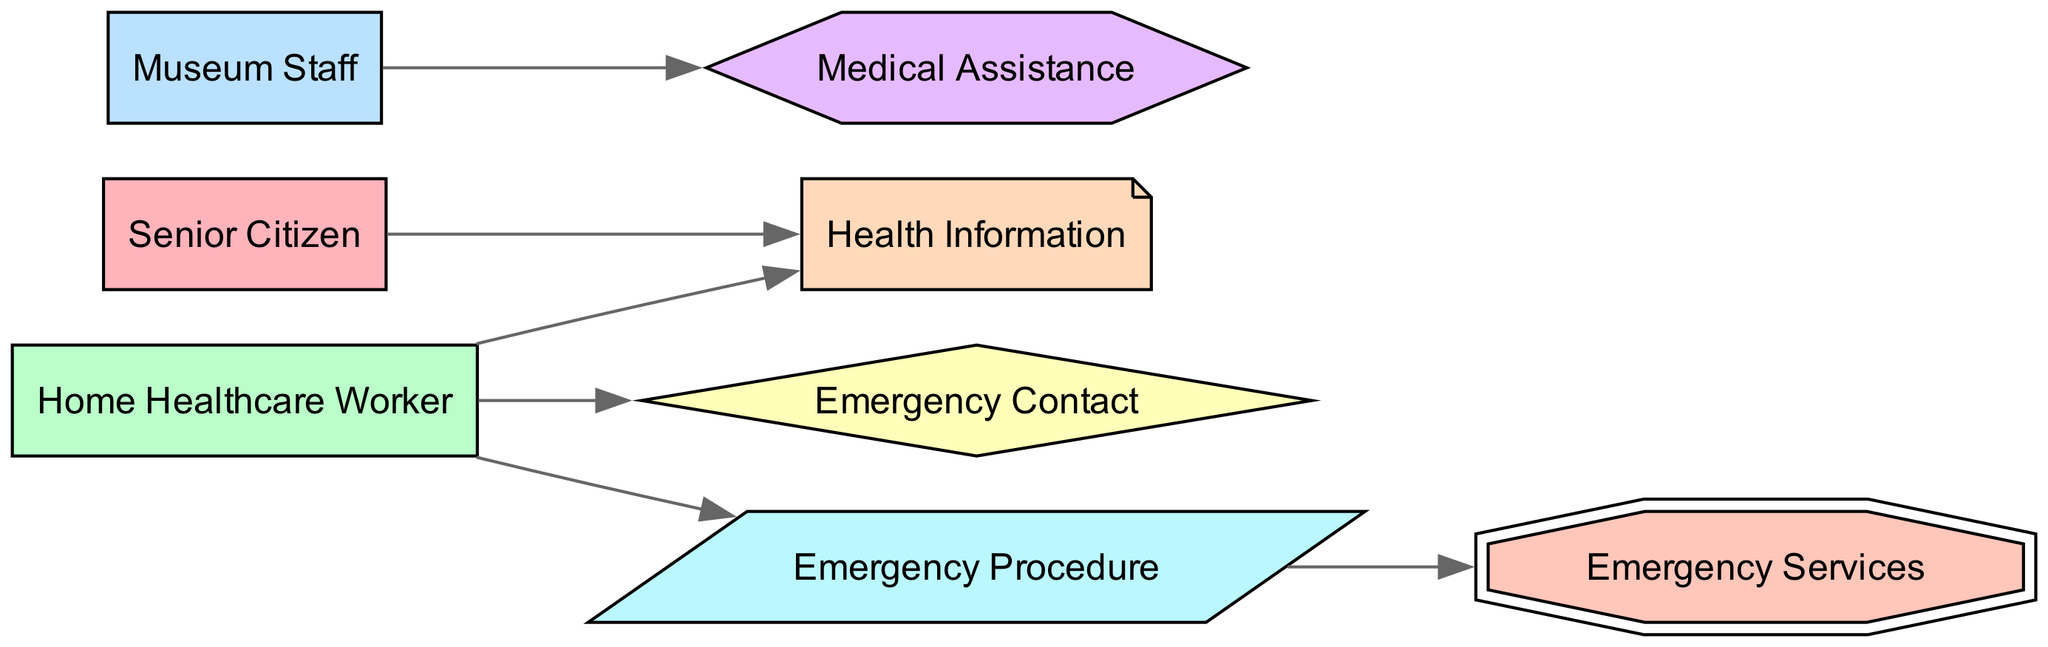What is the total number of nodes in the diagram? The diagram has 8 nodes that represent different entities involved in the emergency contact and health information flow. These nodes are Senior Citizen, Home Healthcare Worker, Museum Staff, Emergency Contact, Health Information, Medical Assistance, Emergency Procedure, and Emergency Services.
Answer: 8 Which node does the Home Healthcare Worker connect to for Health Information? The edge from the Home Healthcare Worker leads directly to the Health Information node, indicating that the worker is responsible for handling health information for the senior citizen.
Answer: Health Information What shape represents the Emergency Procedure node? The Emergency Procedure node is represented by a parallelogram shape, which is indicated as its specific graphical representation in the diagram.
Answer: Parallelogram From which node does Medical Assistance flow? Medical Assistance is connected to Museum Staff, showing that if Medical Assistance is required, it is directly initiated by the Museum Staff.
Answer: Museum Staff How many edges connect the Senior Citizen to other nodes? The Senior Citizen is connected by 1 edge to the Health Information node, indicating that this is the only immediate relationship represented in the diagram.
Answer: 1 Which node is represented as a diamond shape? The Emergency Contact node is represented as a diamond shape, highlighting its unique function in the flow of information.
Answer: Emergency Contact What is the connection from Emergency Procedure to another node? The Emergency Procedure node is connected to Emergency Services, which indicates that once an emergency procedure is initiated, it leads to contacting emergency services.
Answer: Emergency Services Which node has a direct edge to Medical Assistance? The Museum Staff has a direct edge leading to the Medical Assistance node, signifying that they are responsible for providing medical help when needed.
Answer: Museum Staff 